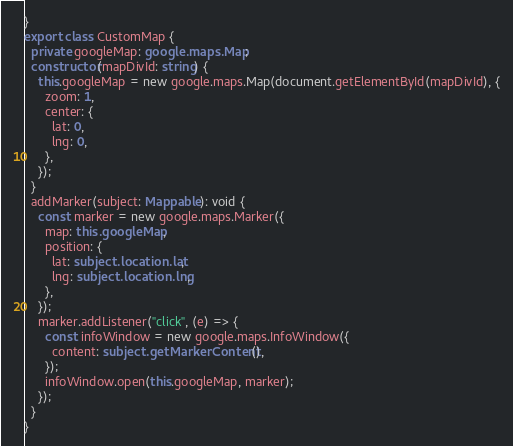<code> <loc_0><loc_0><loc_500><loc_500><_TypeScript_>}
export class CustomMap {
  private googleMap: google.maps.Map;
  constructor(mapDivId: string) {
    this.googleMap = new google.maps.Map(document.getElementById(mapDivId), {
      zoom: 1,
      center: {
        lat: 0,
        lng: 0,
      },
    });
  }
  addMarker(subject: Mappable): void {
    const marker = new google.maps.Marker({
      map: this.googleMap,
      position: {
        lat: subject.location.lat,
        lng: subject.location.lng,
      },
    });
    marker.addListener("click", (e) => {
      const infoWindow = new google.maps.InfoWindow({
        content: subject.getMarkerContent(),
      });
      infoWindow.open(this.googleMap, marker);
    });
  }
}
</code> 